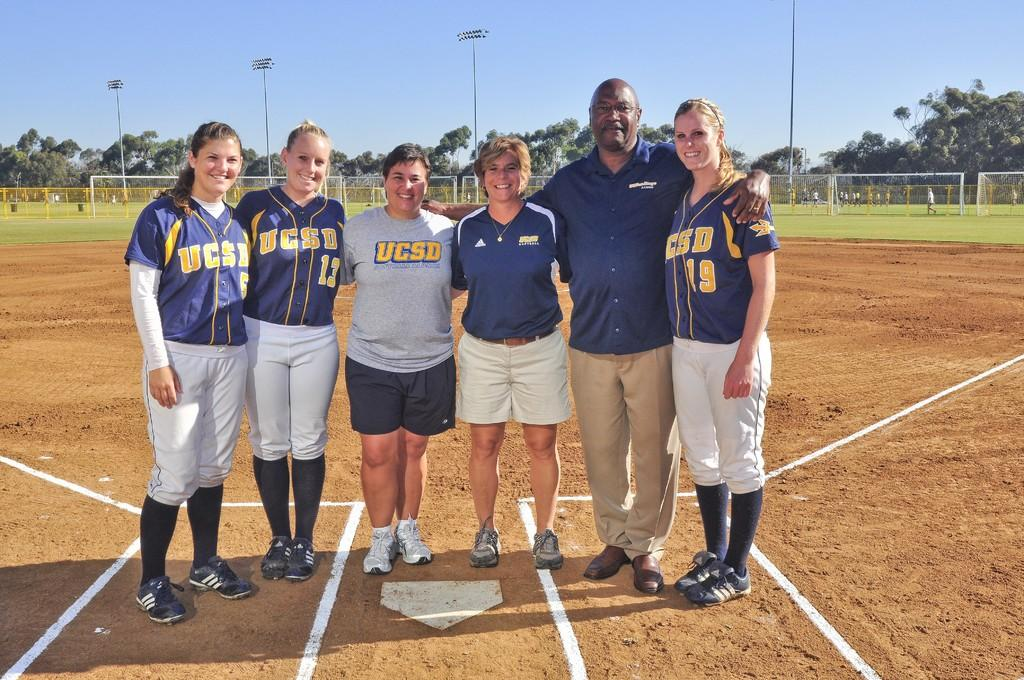<image>
Offer a succinct explanation of the picture presented. A group of people wearing WCS shirts standing by home plate. 